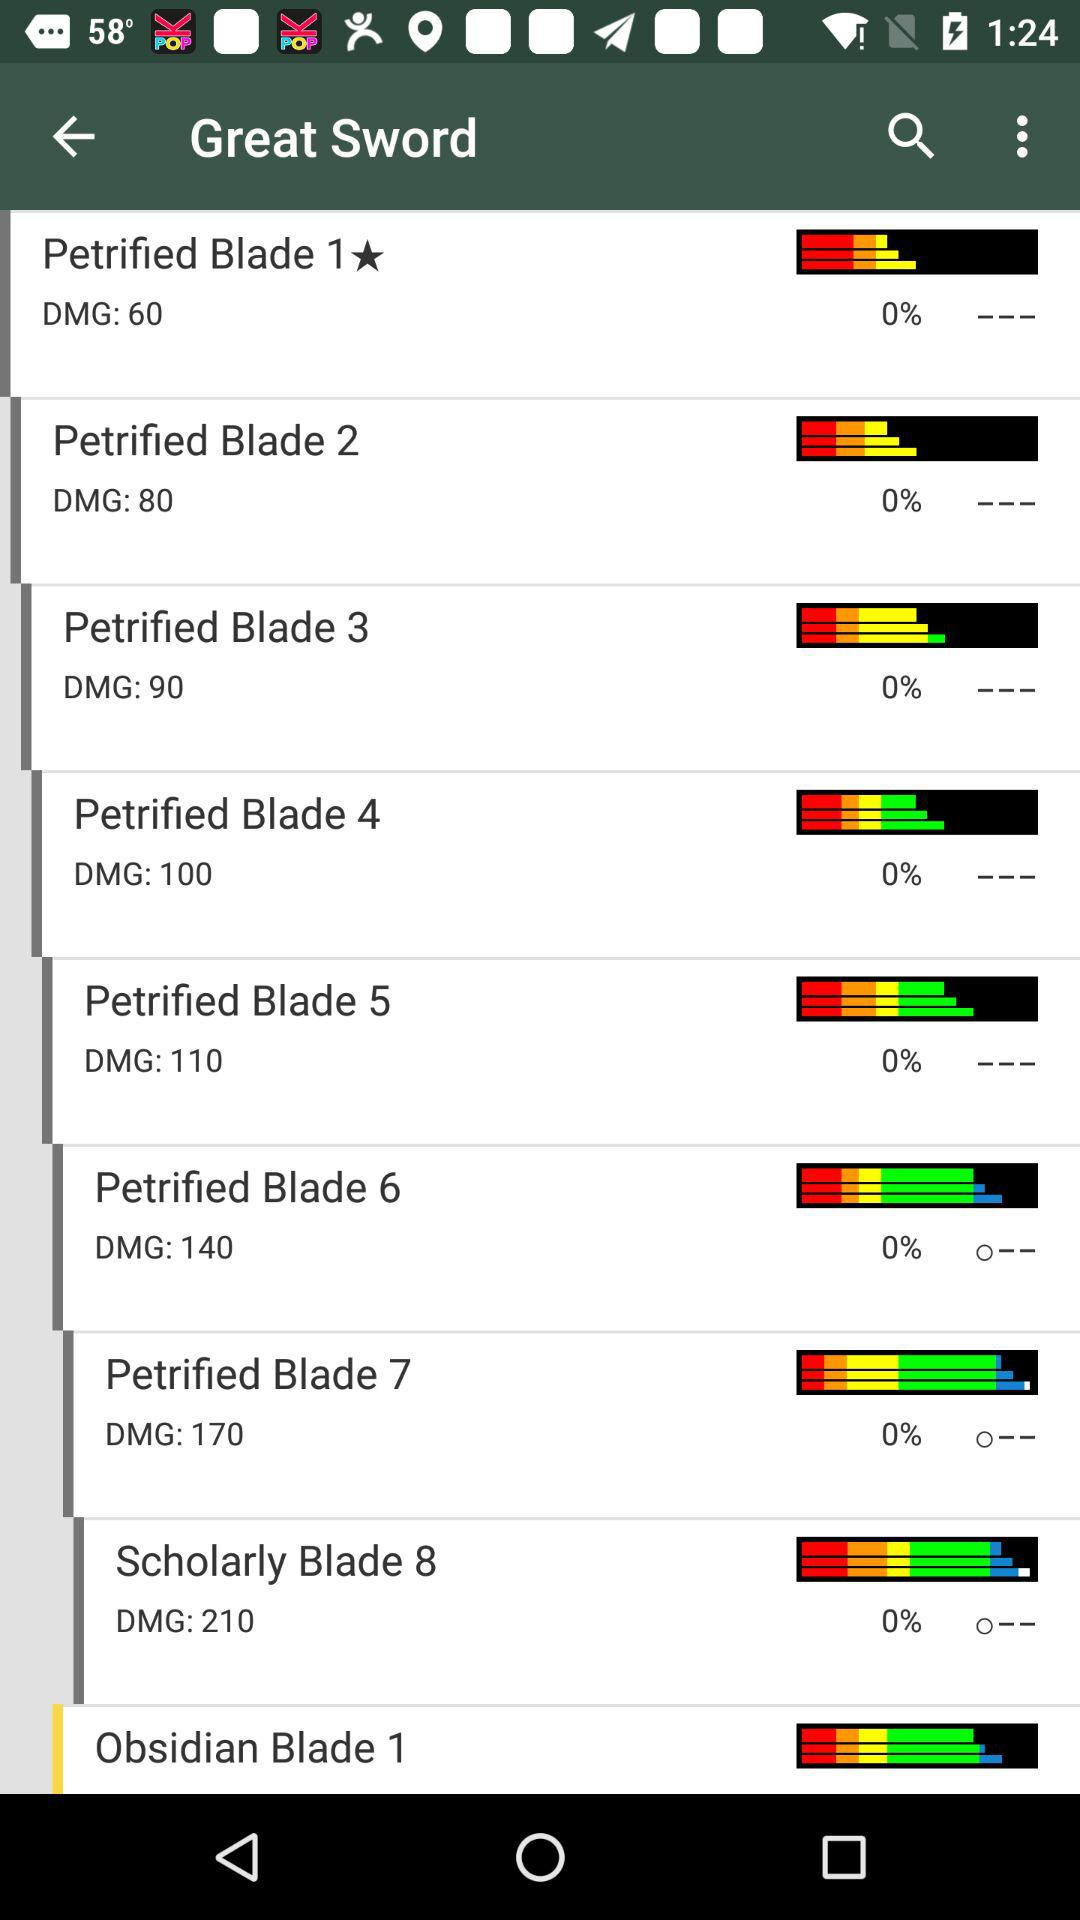What is the DMG number in Petrified Blade 2? The DMG number in Petrified Blade 2 is 80. 